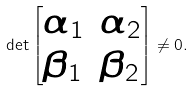Convert formula to latex. <formula><loc_0><loc_0><loc_500><loc_500>\det \begin{bmatrix} \alpha _ { 1 } & \alpha _ { 2 } \\ \beta _ { 1 } & \beta _ { 2 } \end{bmatrix} \ne 0 .</formula> 